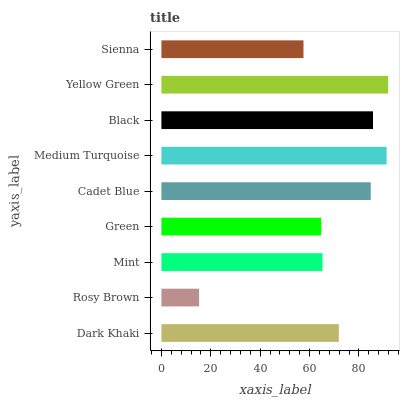Is Rosy Brown the minimum?
Answer yes or no. Yes. Is Yellow Green the maximum?
Answer yes or no. Yes. Is Mint the minimum?
Answer yes or no. No. Is Mint the maximum?
Answer yes or no. No. Is Mint greater than Rosy Brown?
Answer yes or no. Yes. Is Rosy Brown less than Mint?
Answer yes or no. Yes. Is Rosy Brown greater than Mint?
Answer yes or no. No. Is Mint less than Rosy Brown?
Answer yes or no. No. Is Dark Khaki the high median?
Answer yes or no. Yes. Is Dark Khaki the low median?
Answer yes or no. Yes. Is Medium Turquoise the high median?
Answer yes or no. No. Is Rosy Brown the low median?
Answer yes or no. No. 